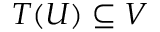<formula> <loc_0><loc_0><loc_500><loc_500>T ( U ) \subseteq V</formula> 